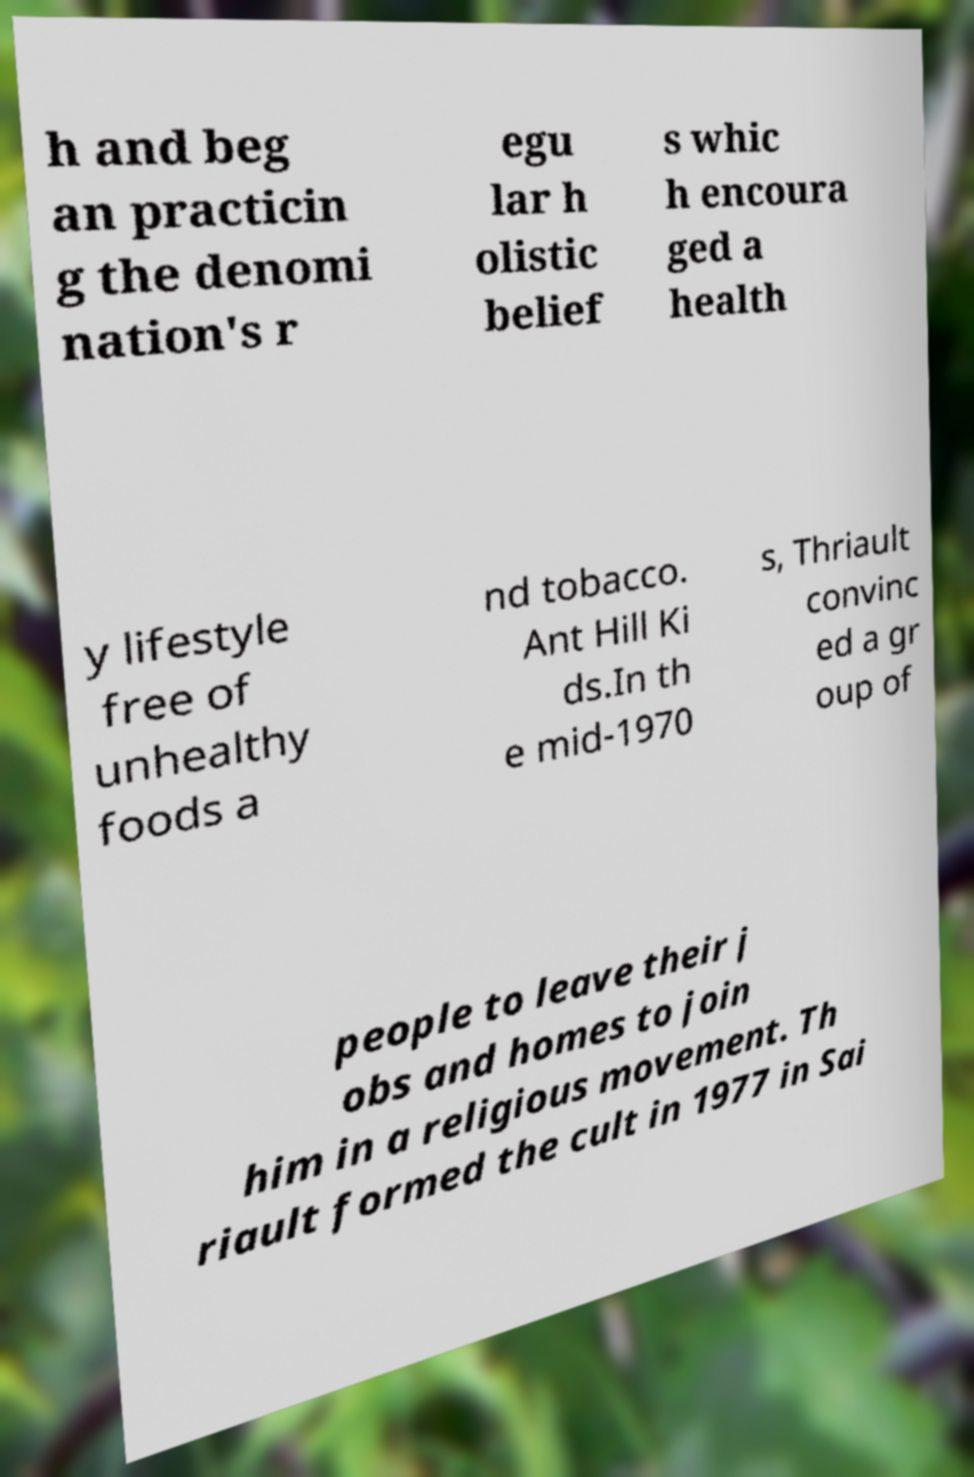Could you extract and type out the text from this image? h and beg an practicin g the denomi nation's r egu lar h olistic belief s whic h encoura ged a health y lifestyle free of unhealthy foods a nd tobacco. Ant Hill Ki ds.In th e mid-1970 s, Thriault convinc ed a gr oup of people to leave their j obs and homes to join him in a religious movement. Th riault formed the cult in 1977 in Sai 